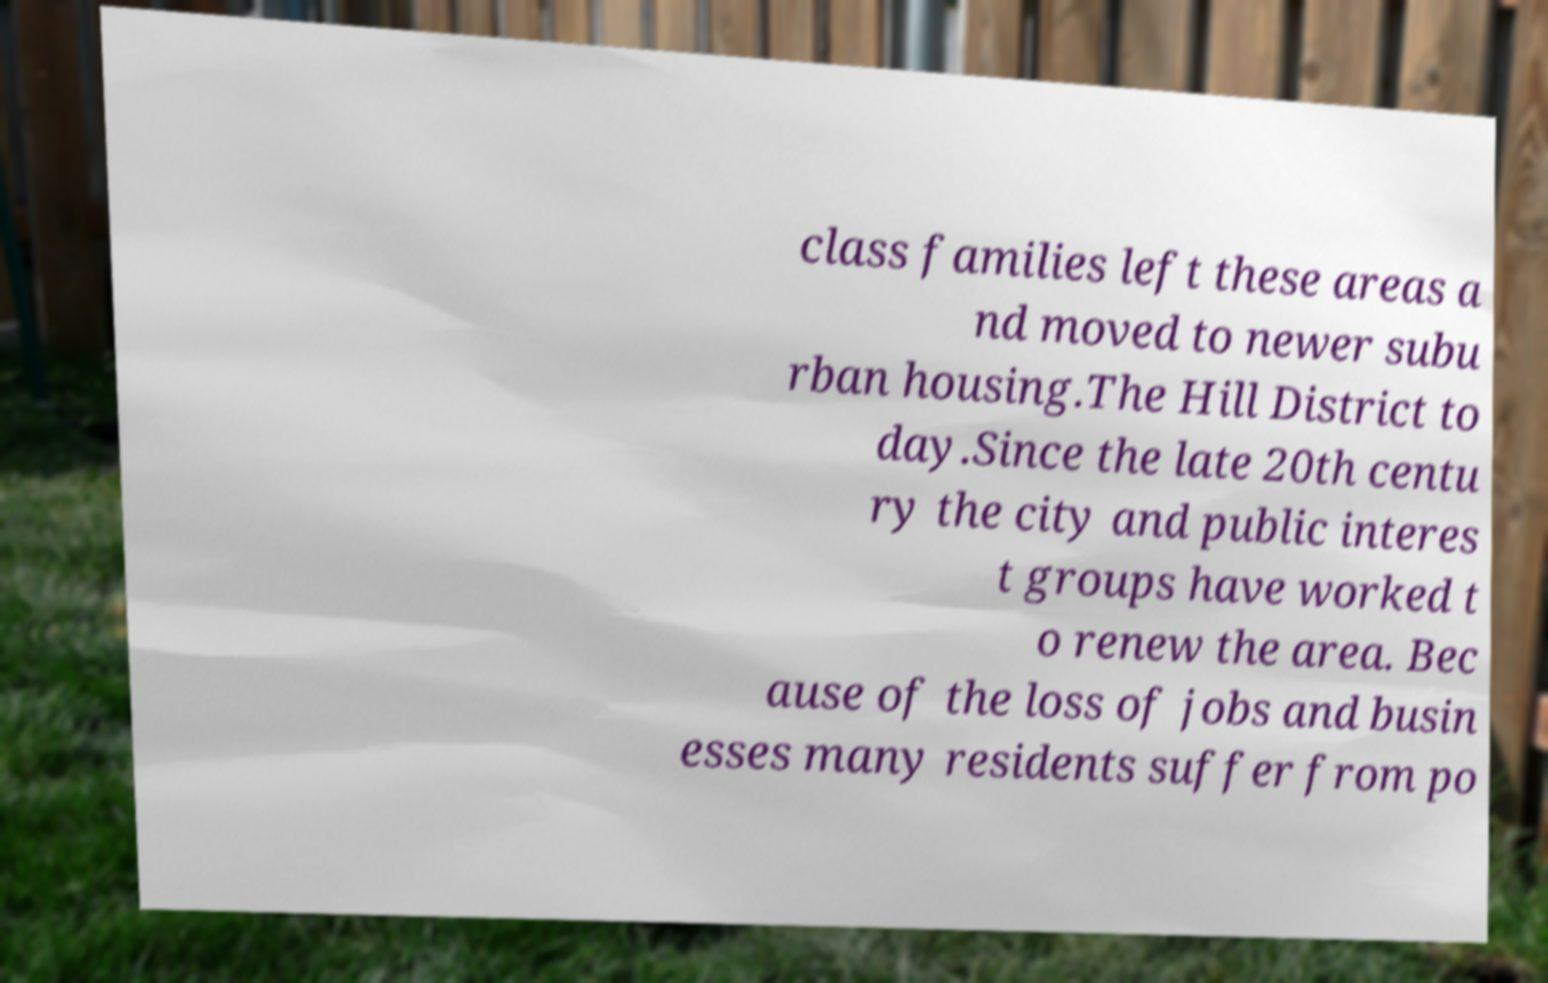I need the written content from this picture converted into text. Can you do that? class families left these areas a nd moved to newer subu rban housing.The Hill District to day.Since the late 20th centu ry the city and public interes t groups have worked t o renew the area. Bec ause of the loss of jobs and busin esses many residents suffer from po 